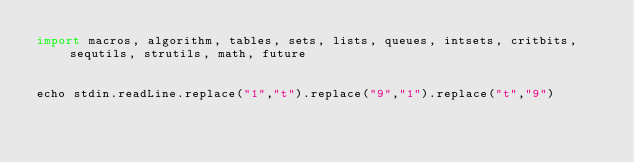Convert code to text. <code><loc_0><loc_0><loc_500><loc_500><_Nim_>import macros, algorithm, tables, sets, lists, queues, intsets, critbits, sequtils, strutils, math, future
 
 
echo stdin.readLine.replace("1","t").replace("9","1").replace("t","9")</code> 